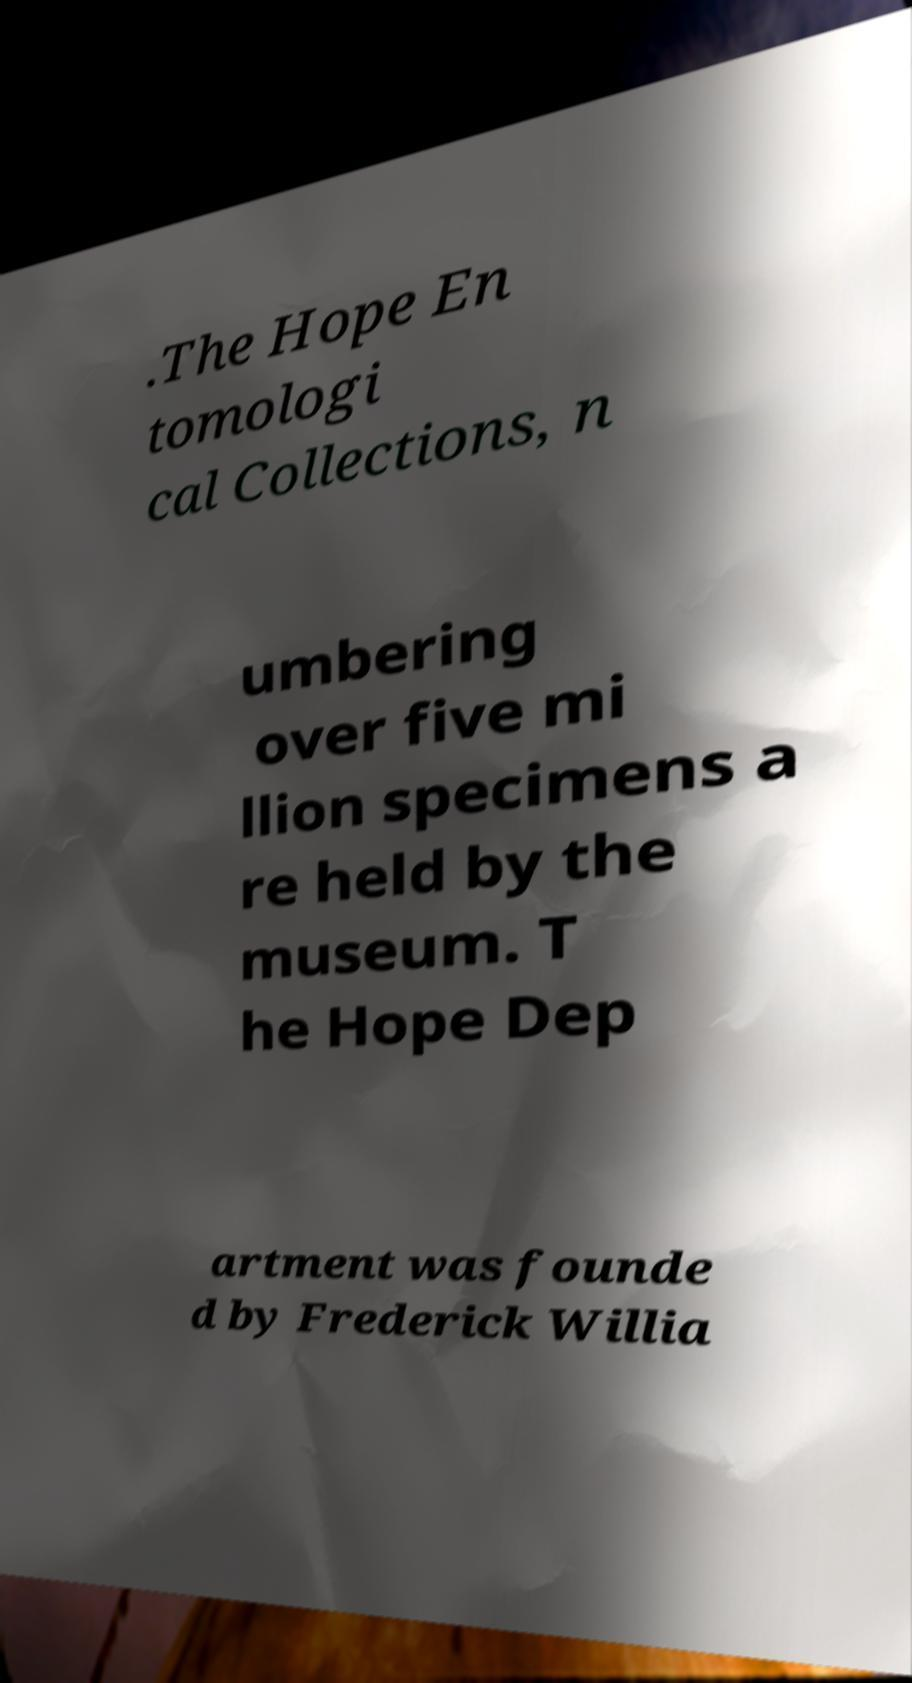There's text embedded in this image that I need extracted. Can you transcribe it verbatim? .The Hope En tomologi cal Collections, n umbering over five mi llion specimens a re held by the museum. T he Hope Dep artment was founde d by Frederick Willia 